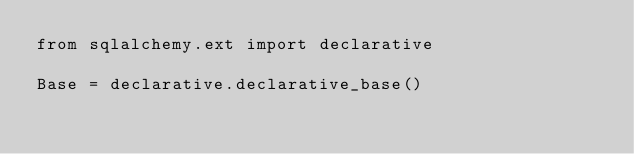<code> <loc_0><loc_0><loc_500><loc_500><_Python_>from sqlalchemy.ext import declarative

Base = declarative.declarative_base()
</code> 